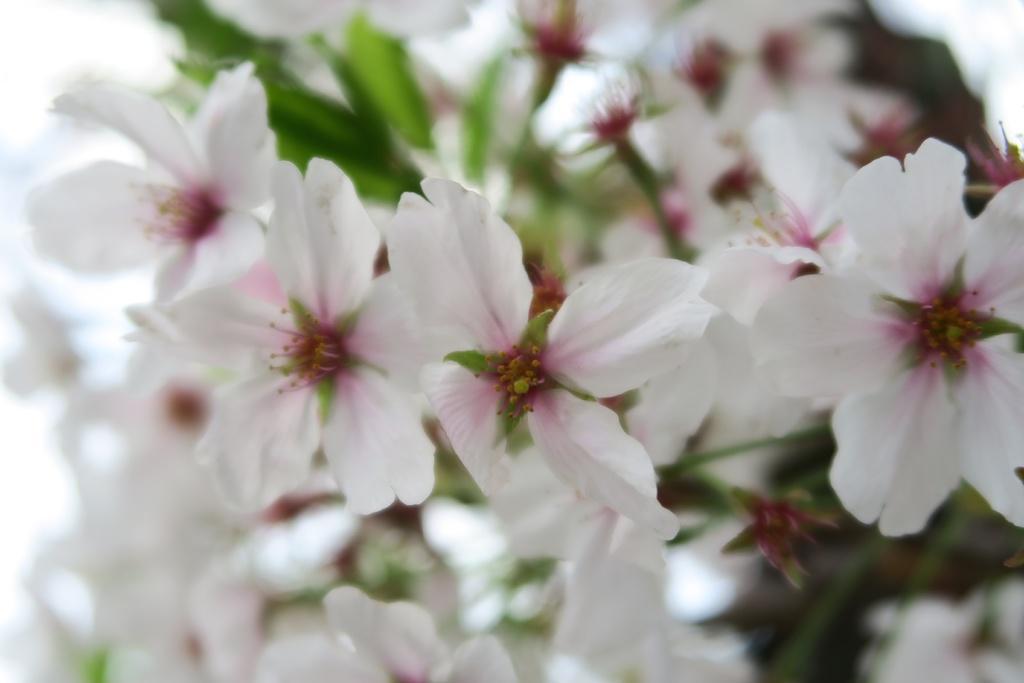In one or two sentences, can you explain what this image depicts? In the picture,there are beautiful white flowers to the plant and the background is blurry. 